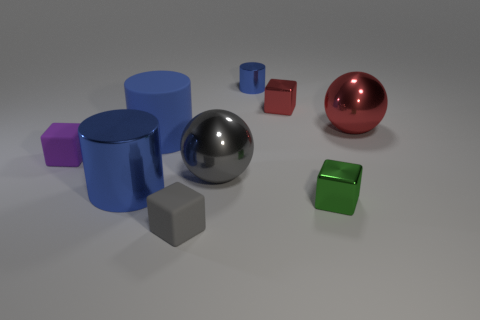Subtract all yellow blocks. Subtract all cyan cylinders. How many blocks are left? 4 Subtract all balls. How many objects are left? 7 Subtract 0 cyan cylinders. How many objects are left? 9 Subtract all large gray shiny objects. Subtract all tiny red metallic cubes. How many objects are left? 7 Add 1 small things. How many small things are left? 6 Add 4 rubber cylinders. How many rubber cylinders exist? 5 